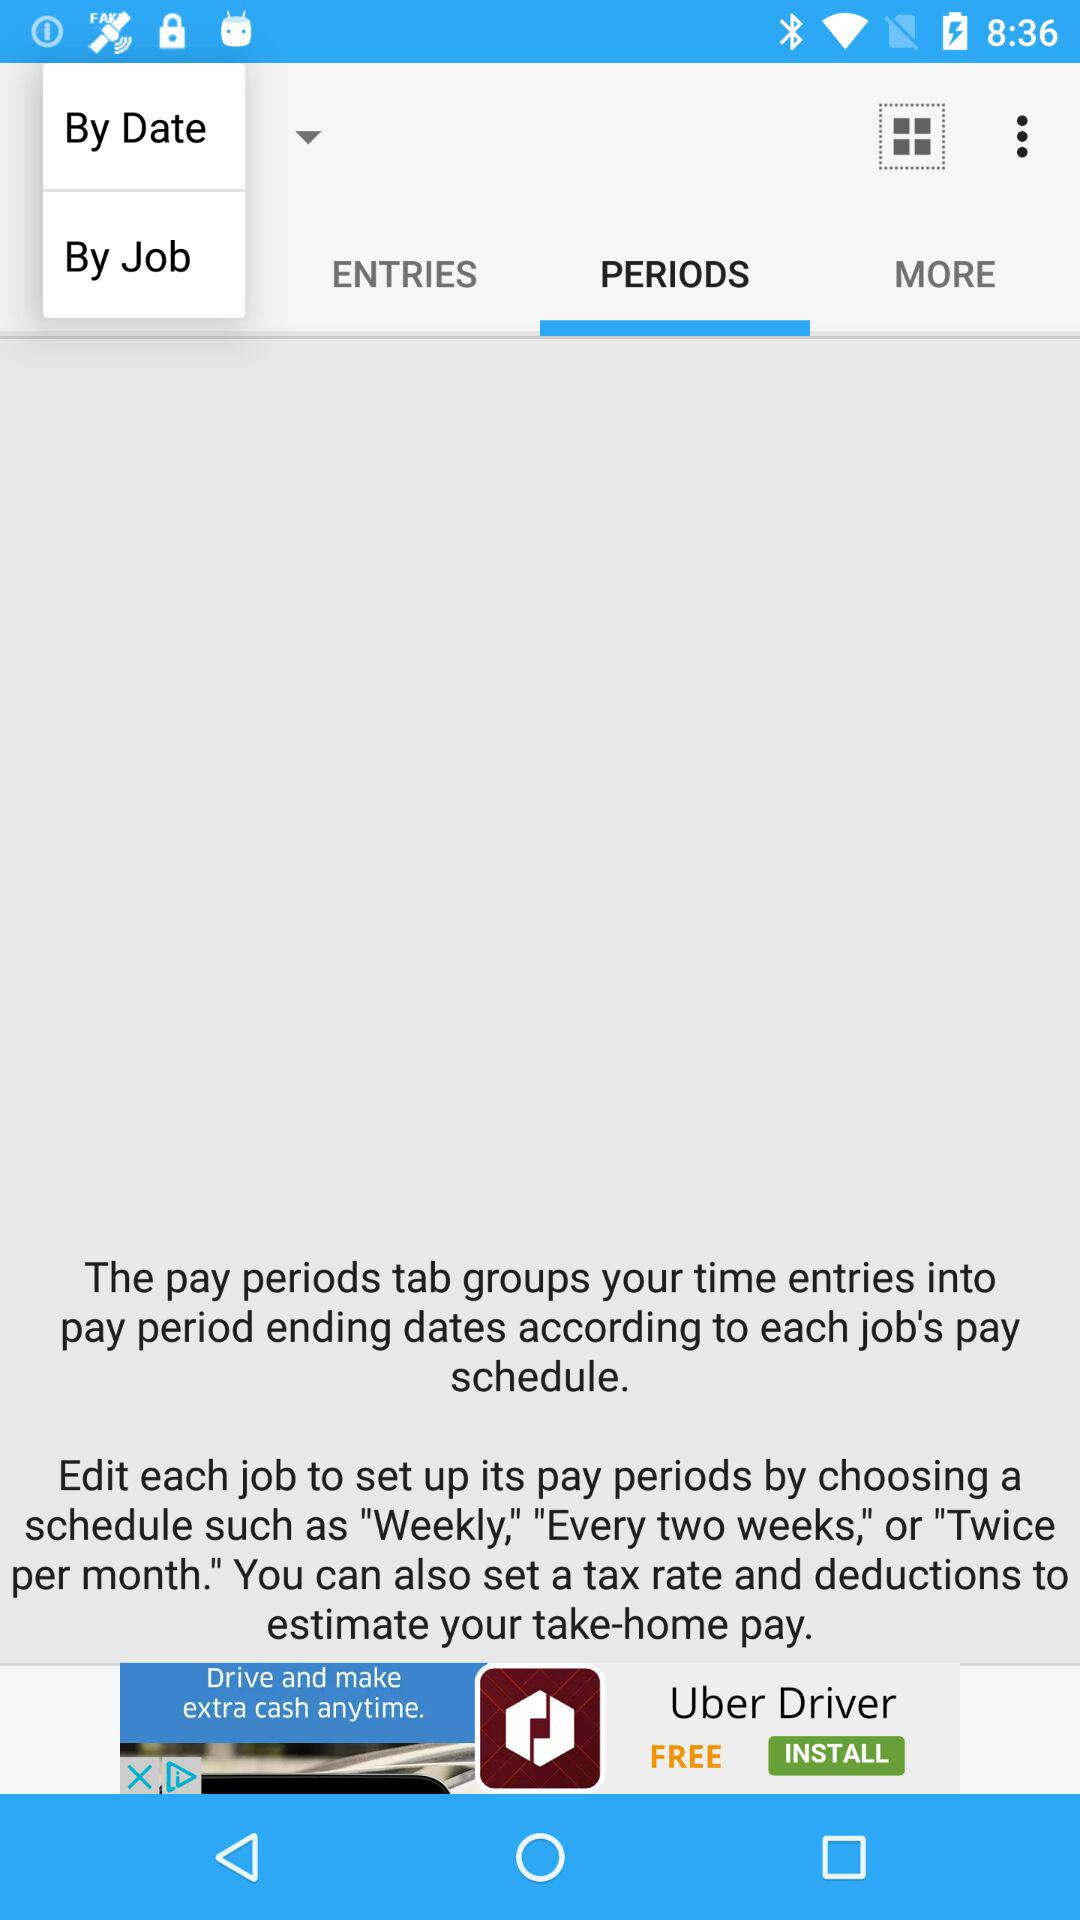Which tab is selected? The selected tab is "PERIODS". 